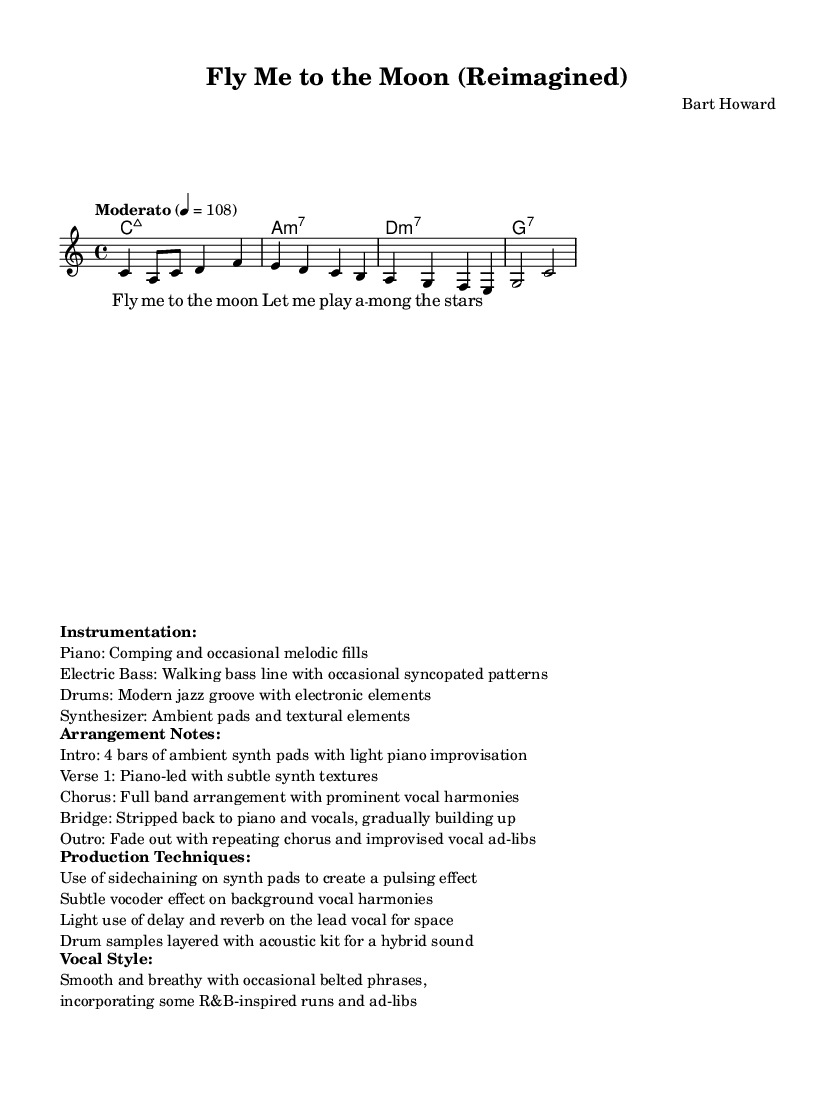What is the key signature of this music? The key signature is indicated at the beginning of the score and shows no sharps or flats, confirming it is in C major.
Answer: C major What is the time signature of this piece? The time signature is shown at the beginning of the score, which is commonly placed right after the key signature, and it reads 4/4.
Answer: 4/4 What is the tempo marking for this piece? The tempo marking is provided in the score using the term "Moderato" followed by a metronome marking of 4 = 108, indicating the speed at which to perform the piece.
Answer: Moderato How many measures are in the melody? By counting the measures found in the melody part, there are a total of 4 measures.
Answer: 4 What is the style of the vocal performance described? The vocal style is indicated in the score's markup section and describes it as "Smooth and breathy with occasional belted phrases, incorporating some R&B-inspired runs and ad-libs."
Answer: Smooth and breathy How does the arrangement approach the bridge section? The arrangement notes explain that the bridge is "stripped back to piano and vocals, gradually building up," which indicates a specific approach to dynamics and texture in that part of the piece.
Answer: Stripped back Which instruments are involved in the arrangement? The instrumentation is listed in the markup section, where it mentions Piano, Electric Bass, Drums, and Synthesizer as primary instruments used in the arrangement.
Answer: Piano, Electric Bass, Drums, Synthesizer 